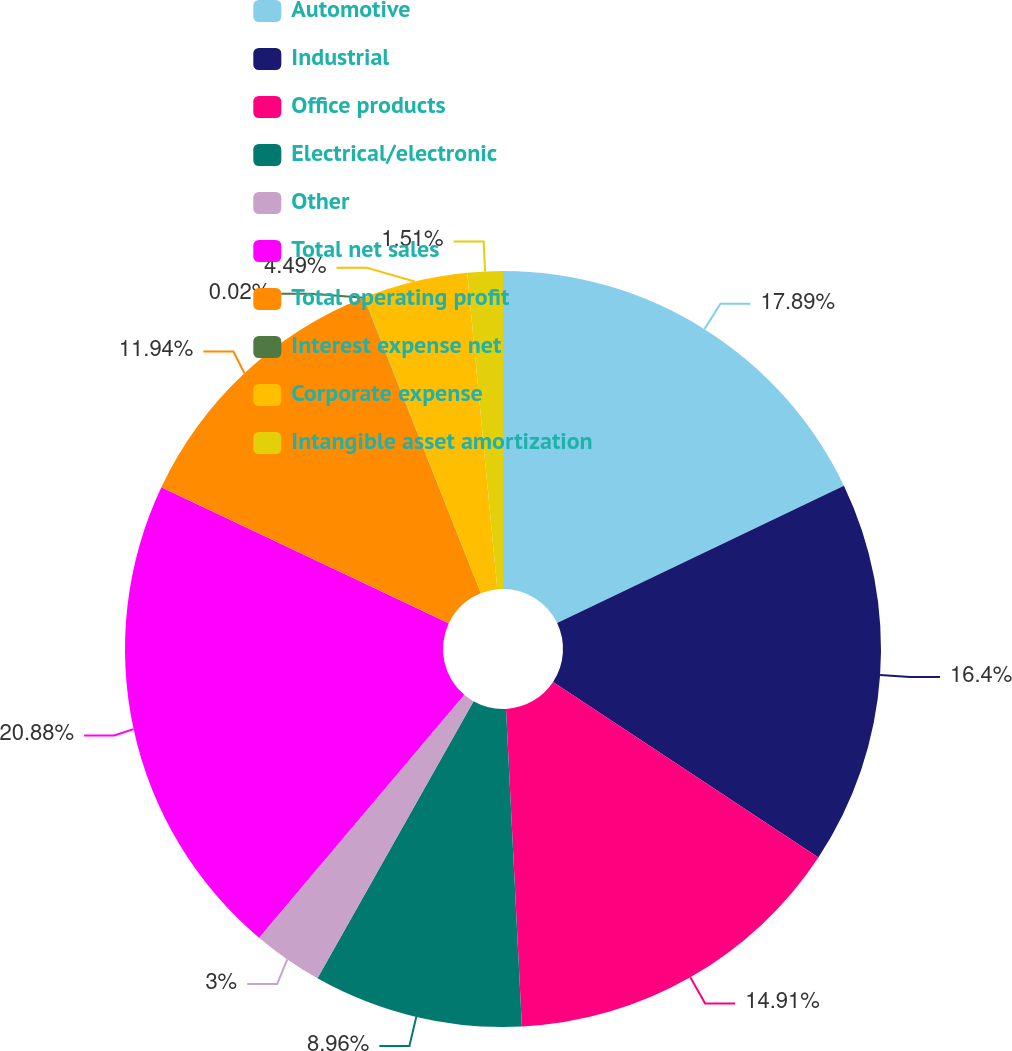<chart> <loc_0><loc_0><loc_500><loc_500><pie_chart><fcel>Automotive<fcel>Industrial<fcel>Office products<fcel>Electrical/electronic<fcel>Other<fcel>Total net sales<fcel>Total operating profit<fcel>Interest expense net<fcel>Corporate expense<fcel>Intangible asset amortization<nl><fcel>17.89%<fcel>16.4%<fcel>14.91%<fcel>8.96%<fcel>3.0%<fcel>20.87%<fcel>11.94%<fcel>0.02%<fcel>4.49%<fcel>1.51%<nl></chart> 